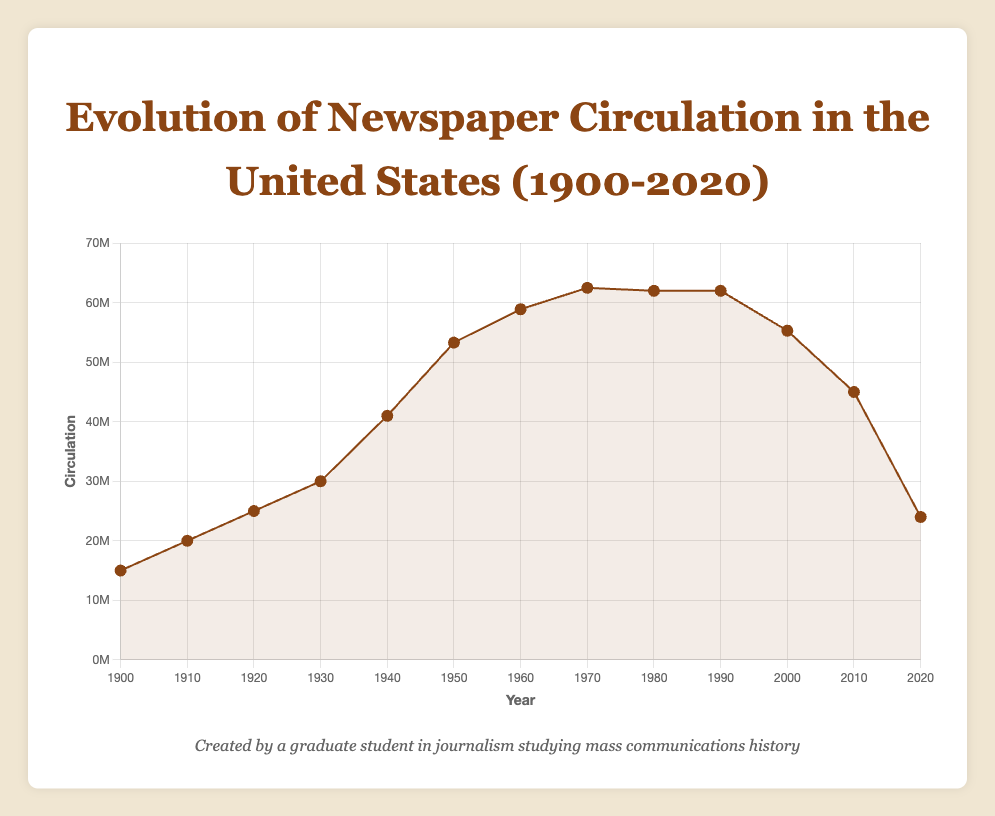What is the highest circulation recorded between 1900 and 2020? We need to look for the highest point on the line plot, which corresponds to the year 1970 with a circulation of 62,500,000.
Answer: 62,500,000 In which decade did newspaper circulation experience the largest increase? The largest increase in circulation is between 1940 and 1950. It rises from 41,000,000 to 53,300,000, an increase of 12,300,000.
Answer: 1940-1950 During which year(s) did newspaper circulation remain constant? By observing the line plot, we see that from 1980 to 1990, the circulation remains constant at 62,000,000.
Answer: 1980-1990 What is the difference in newspaper circulation between the peak year and the year 2020? The peak circulation is 62,500,000 in 1970 and in 2020 it is 24,000,000. The difference is 62,500,000 - 24,000,000 = 38,500,000.
Answer: 38,500,000 By how much did newspaper circulation decrease from 2010 to 2020? In 2010, circulation was 45,000,000, and in 2020 it was 24,000,000. The decrease is 45,000,000 - 24,000,000 = 21,000,000.
Answer: 21,000,000 Compare the average newspaper circulation in the decades 1920s and 2010s. For 1920s, circulation is 25,000,000. For 2010s, the average is (45,000,000 + 24,000,000)/2 = 34,500,000. Hence, circulation was lower in the 1920s.
Answer: 1920s < 2010s What can you infer about the trend of newspaper circulation from 2000 to 2020? The trend shows a steady decline in circulation, decreasing from 55,300,000 in 2000 to 24,000,000 in 2020.
Answer: Declining By how much did the newspaper circulation increase from 1900 to 1970? The circulation in 1900 was 15,000,000 and in 1970 it was 62,500,000. The increase is 62,500,000 - 15,000,000 = 47,500,000.
Answer: 47,500,000 What is the average newspaper circulation for the entire period from 1900 to 2020? Sum all the circulations and divide by the number of years: (15,000,000 + 20,000,000 + 25,000,000 + 30,000,000 + 41,000,000 + 53,300,000 + 58,900,000 + 62,500,000 + 62,000,000 + 62,000,000 + 55,300,000 + 45,000,000 + 24,000,000) / 13 = 42,230,769.23
Answer: 42,230,769.23 